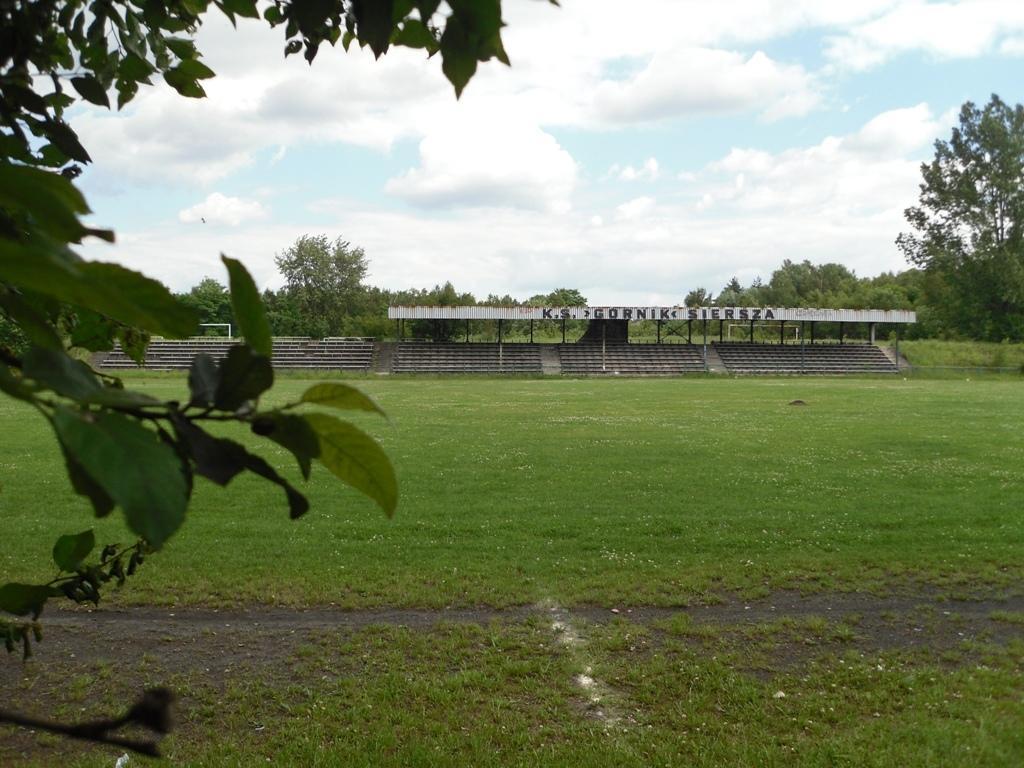Could you give a brief overview of what you see in this image? In this picture there is a shirt, beside that i can see the stairs. In the background i can see many trees. On the right there is a bird which is flying in the air. On the right i can see the plants and grass. At the top i can see the sky and clouds. 